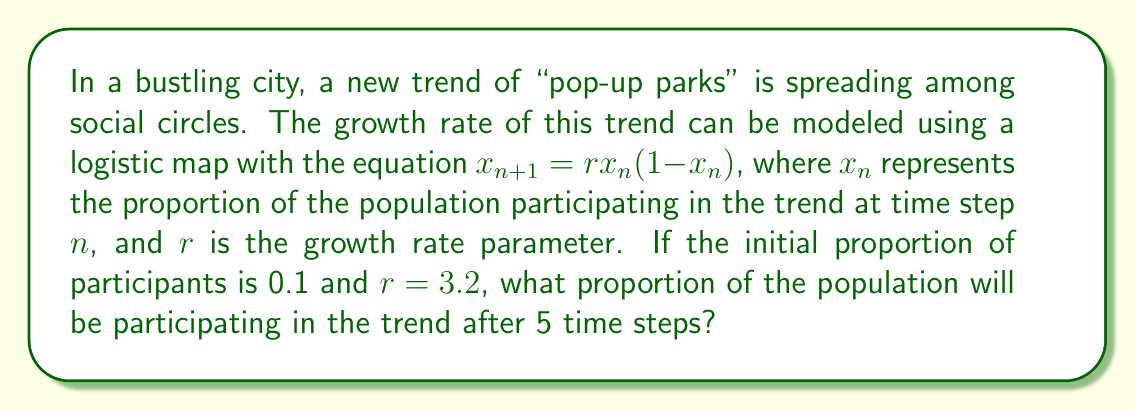Provide a solution to this math problem. To solve this problem, we need to iterate the logistic map equation for 5 time steps:

1) Initial condition: $x_0 = 0.1$
2) Growth rate parameter: $r = 3.2$
3) Logistic map equation: $x_{n+1} = rx_n(1-x_n)$

Let's calculate each step:

Step 1: $x_1 = 3.2 \cdot 0.1 \cdot (1-0.1) = 0.288$

Step 2: $x_2 = 3.2 \cdot 0.288 \cdot (1-0.288) = 0.656$

Step 3: $x_3 = 3.2 \cdot 0.656 \cdot (1-0.656) = 0.722$

Step 4: $x_4 = 3.2 \cdot 0.722 \cdot (1-0.722) = 0.642$

Step 5: $x_5 = 3.2 \cdot 0.642 \cdot (1-0.642) = 0.735$

Therefore, after 5 time steps, the proportion of the population participating in the "pop-up parks" trend will be approximately 0.735 or 73.5%.
Answer: 0.735 